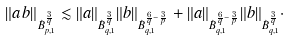Convert formula to latex. <formula><loc_0><loc_0><loc_500><loc_500>\| a \, b \| _ { \dot { B } ^ { \frac { 3 } { q } } _ { p , 1 } } \lesssim \| a \| _ { \dot { B } ^ { \frac { 3 } { q } } _ { q , 1 } } \| b \| _ { \dot { B } ^ { \frac { 6 } { q } - \frac { 3 } { p } } _ { q , 1 } } + \| a \| _ { \dot { B } ^ { \frac { 6 } { q } - \frac { 3 } { p } } _ { q , 1 } } \| b \| _ { \dot { B } ^ { \frac { 3 } { q } } _ { q , 1 } } \cdot</formula> 